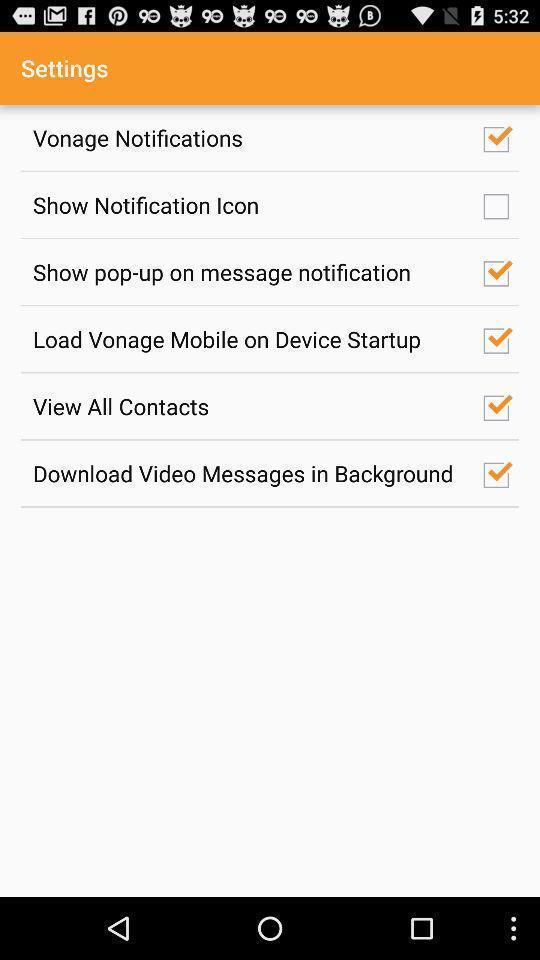Provide a textual representation of this image. Settings page. 